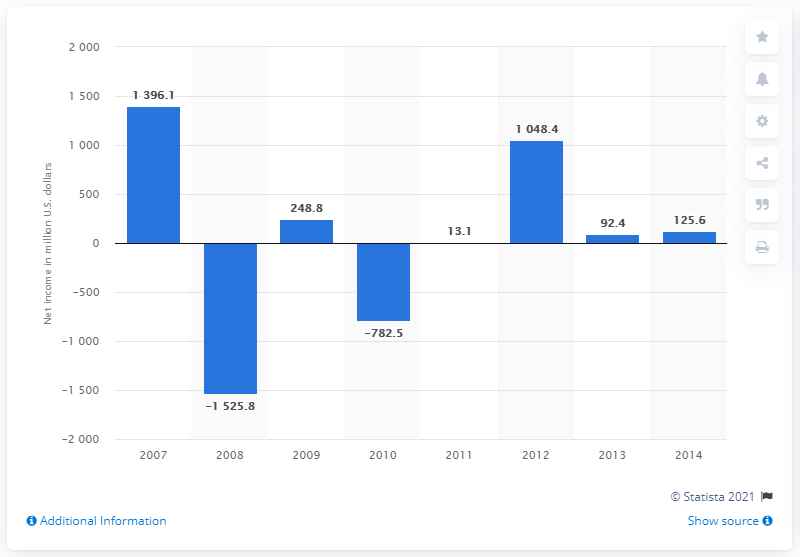List a handful of essential elements in this visual. The previous year's net income was 92,400. AOL's net income in 2014 was 125.6 million dollars. 